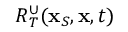<formula> <loc_0><loc_0><loc_500><loc_500>R _ { T } ^ { \cup } ( { x } _ { S } , { x } , t )</formula> 